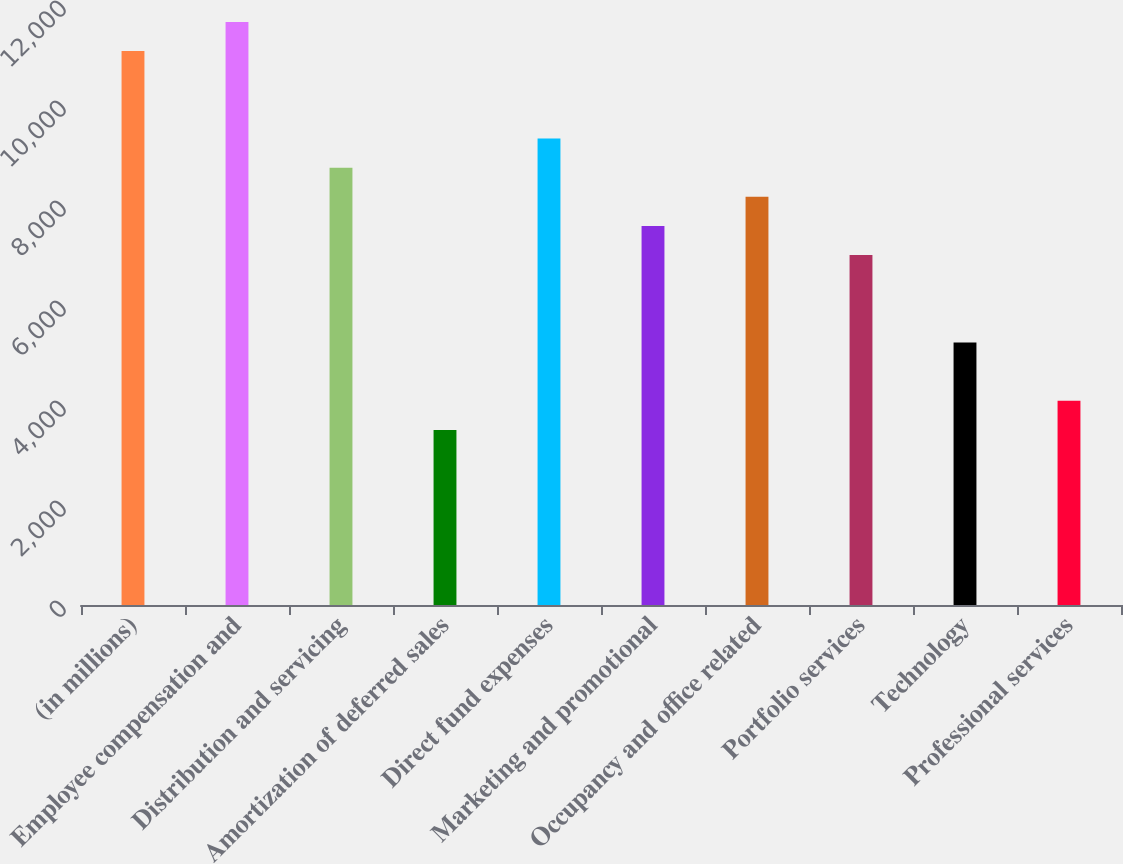Convert chart to OTSL. <chart><loc_0><loc_0><loc_500><loc_500><bar_chart><fcel>(in millions)<fcel>Employee compensation and<fcel>Distribution and servicing<fcel>Amortization of deferred sales<fcel>Direct fund expenses<fcel>Marketing and promotional<fcel>Occupancy and office related<fcel>Portfolio services<fcel>Technology<fcel>Professional services<nl><fcel>11078.1<fcel>11661<fcel>8746.5<fcel>3500.4<fcel>9329.4<fcel>7580.7<fcel>8163.6<fcel>6997.8<fcel>5249.1<fcel>4083.3<nl></chart> 